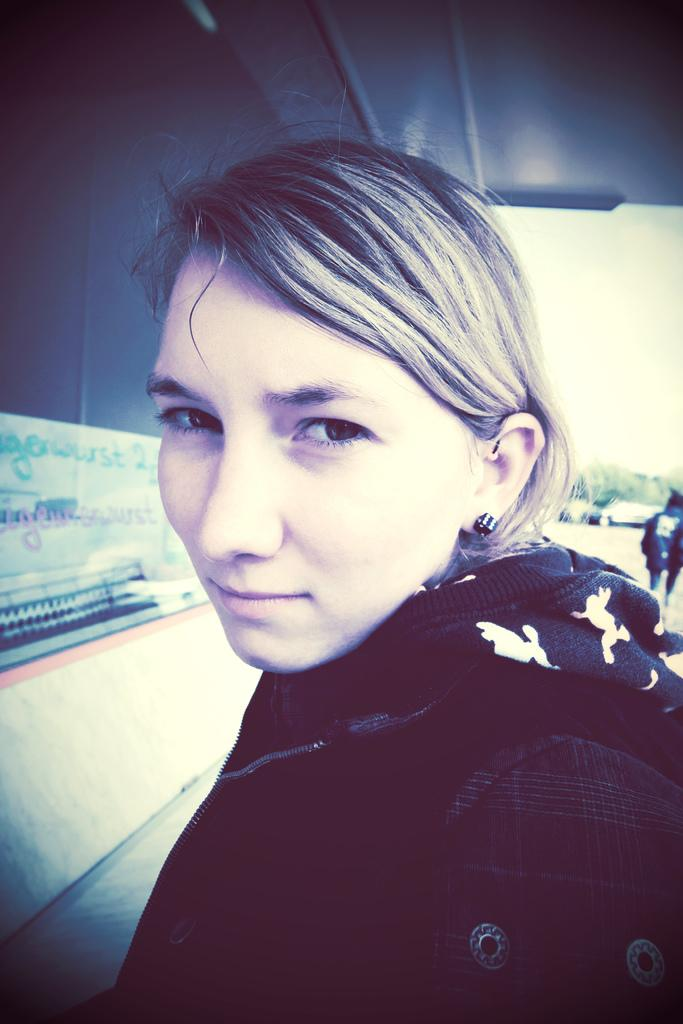Who is the main subject in the image? There is a woman in the image. What is the woman wearing? The woman is wearing black clothes. Can you describe the person in the background of the image? There is a person standing in the background of the image. What else can be seen in the background of the image? There are other objects visible in the background of the image. What type of cake is being served on the island in the image? There is no cake or island present in the image; it features a woman wearing black clothes and a person standing in the background. 